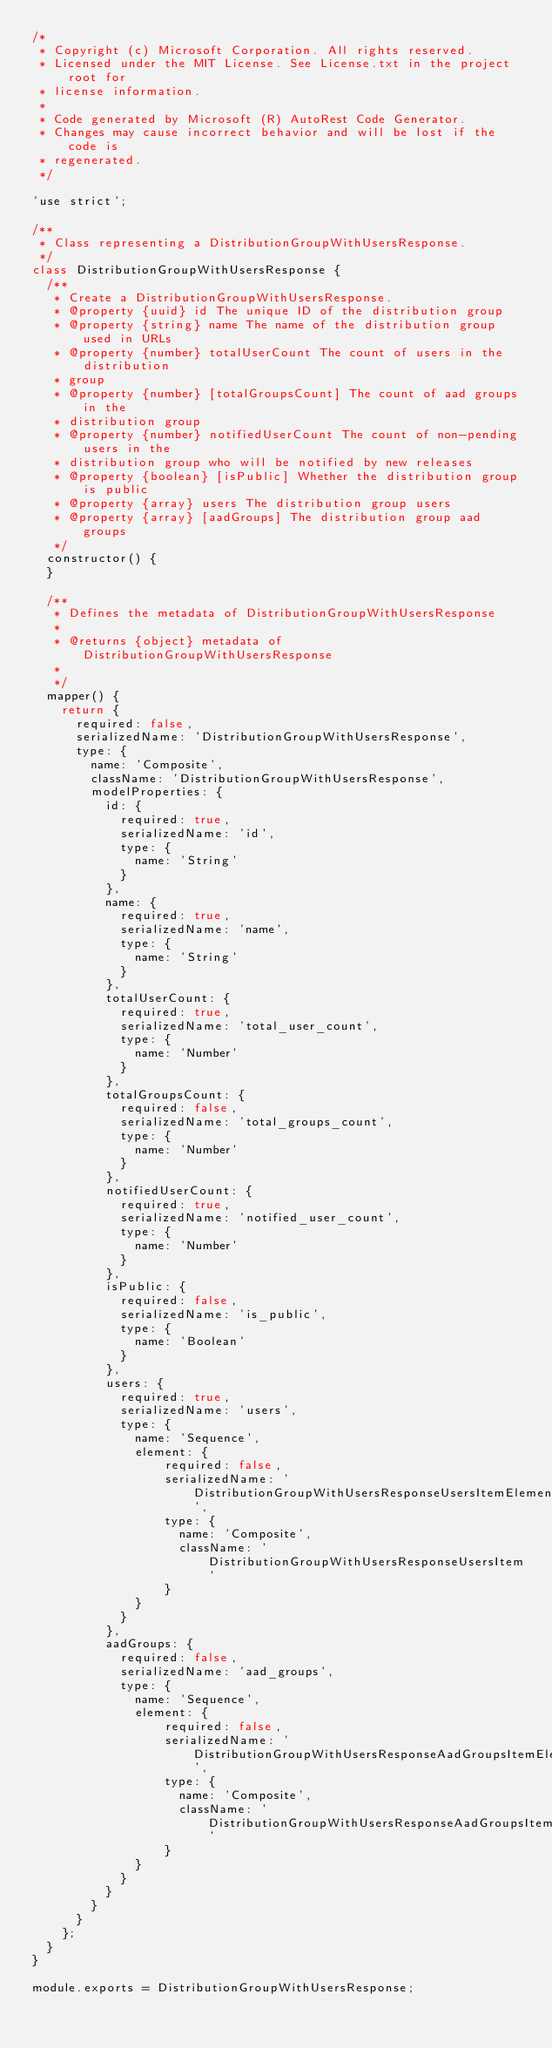<code> <loc_0><loc_0><loc_500><loc_500><_JavaScript_>/*
 * Copyright (c) Microsoft Corporation. All rights reserved.
 * Licensed under the MIT License. See License.txt in the project root for
 * license information.
 *
 * Code generated by Microsoft (R) AutoRest Code Generator.
 * Changes may cause incorrect behavior and will be lost if the code is
 * regenerated.
 */

'use strict';

/**
 * Class representing a DistributionGroupWithUsersResponse.
 */
class DistributionGroupWithUsersResponse {
  /**
   * Create a DistributionGroupWithUsersResponse.
   * @property {uuid} id The unique ID of the distribution group
   * @property {string} name The name of the distribution group used in URLs
   * @property {number} totalUserCount The count of users in the distribution
   * group
   * @property {number} [totalGroupsCount] The count of aad groups in the
   * distribution group
   * @property {number} notifiedUserCount The count of non-pending users in the
   * distribution group who will be notified by new releases
   * @property {boolean} [isPublic] Whether the distribution group is public
   * @property {array} users The distribution group users
   * @property {array} [aadGroups] The distribution group aad groups
   */
  constructor() {
  }

  /**
   * Defines the metadata of DistributionGroupWithUsersResponse
   *
   * @returns {object} metadata of DistributionGroupWithUsersResponse
   *
   */
  mapper() {
    return {
      required: false,
      serializedName: 'DistributionGroupWithUsersResponse',
      type: {
        name: 'Composite',
        className: 'DistributionGroupWithUsersResponse',
        modelProperties: {
          id: {
            required: true,
            serializedName: 'id',
            type: {
              name: 'String'
            }
          },
          name: {
            required: true,
            serializedName: 'name',
            type: {
              name: 'String'
            }
          },
          totalUserCount: {
            required: true,
            serializedName: 'total_user_count',
            type: {
              name: 'Number'
            }
          },
          totalGroupsCount: {
            required: false,
            serializedName: 'total_groups_count',
            type: {
              name: 'Number'
            }
          },
          notifiedUserCount: {
            required: true,
            serializedName: 'notified_user_count',
            type: {
              name: 'Number'
            }
          },
          isPublic: {
            required: false,
            serializedName: 'is_public',
            type: {
              name: 'Boolean'
            }
          },
          users: {
            required: true,
            serializedName: 'users',
            type: {
              name: 'Sequence',
              element: {
                  required: false,
                  serializedName: 'DistributionGroupWithUsersResponseUsersItemElementType',
                  type: {
                    name: 'Composite',
                    className: 'DistributionGroupWithUsersResponseUsersItem'
                  }
              }
            }
          },
          aadGroups: {
            required: false,
            serializedName: 'aad_groups',
            type: {
              name: 'Sequence',
              element: {
                  required: false,
                  serializedName: 'DistributionGroupWithUsersResponseAadGroupsItemElementType',
                  type: {
                    name: 'Composite',
                    className: 'DistributionGroupWithUsersResponseAadGroupsItem'
                  }
              }
            }
          }
        }
      }
    };
  }
}

module.exports = DistributionGroupWithUsersResponse;
</code> 